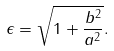<formula> <loc_0><loc_0><loc_500><loc_500>\epsilon = \sqrt { 1 + \frac { b ^ { 2 } } { a ^ { 2 } } } .</formula> 